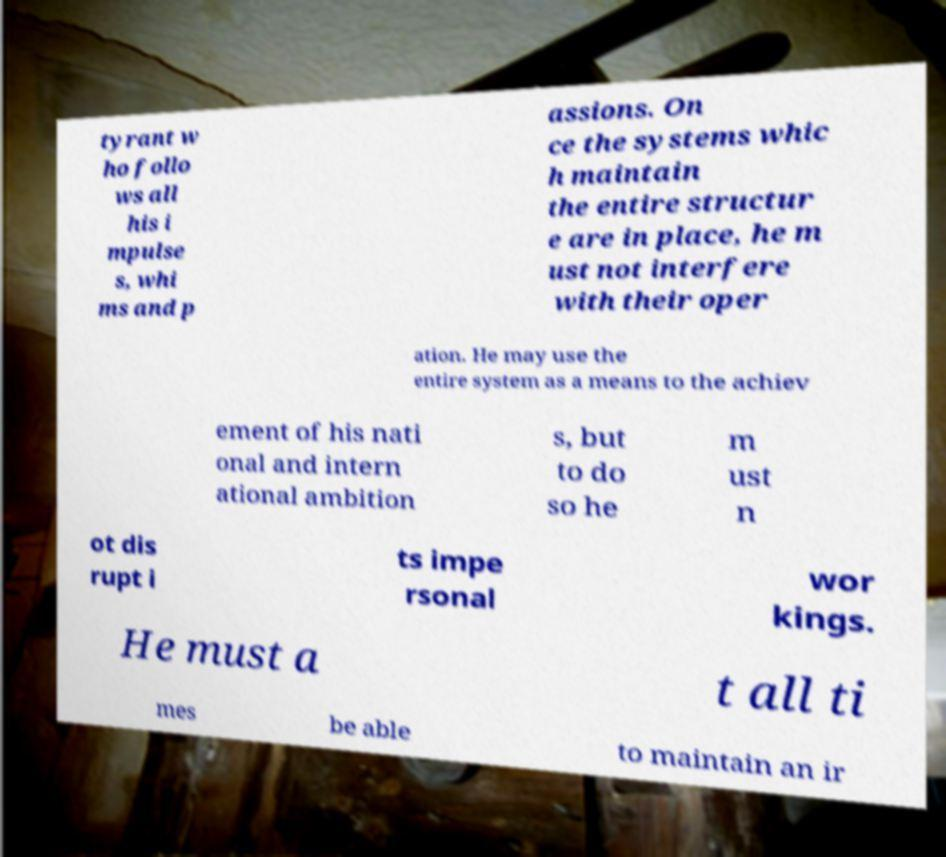Could you assist in decoding the text presented in this image and type it out clearly? tyrant w ho follo ws all his i mpulse s, whi ms and p assions. On ce the systems whic h maintain the entire structur e are in place, he m ust not interfere with their oper ation. He may use the entire system as a means to the achiev ement of his nati onal and intern ational ambition s, but to do so he m ust n ot dis rupt i ts impe rsonal wor kings. He must a t all ti mes be able to maintain an ir 